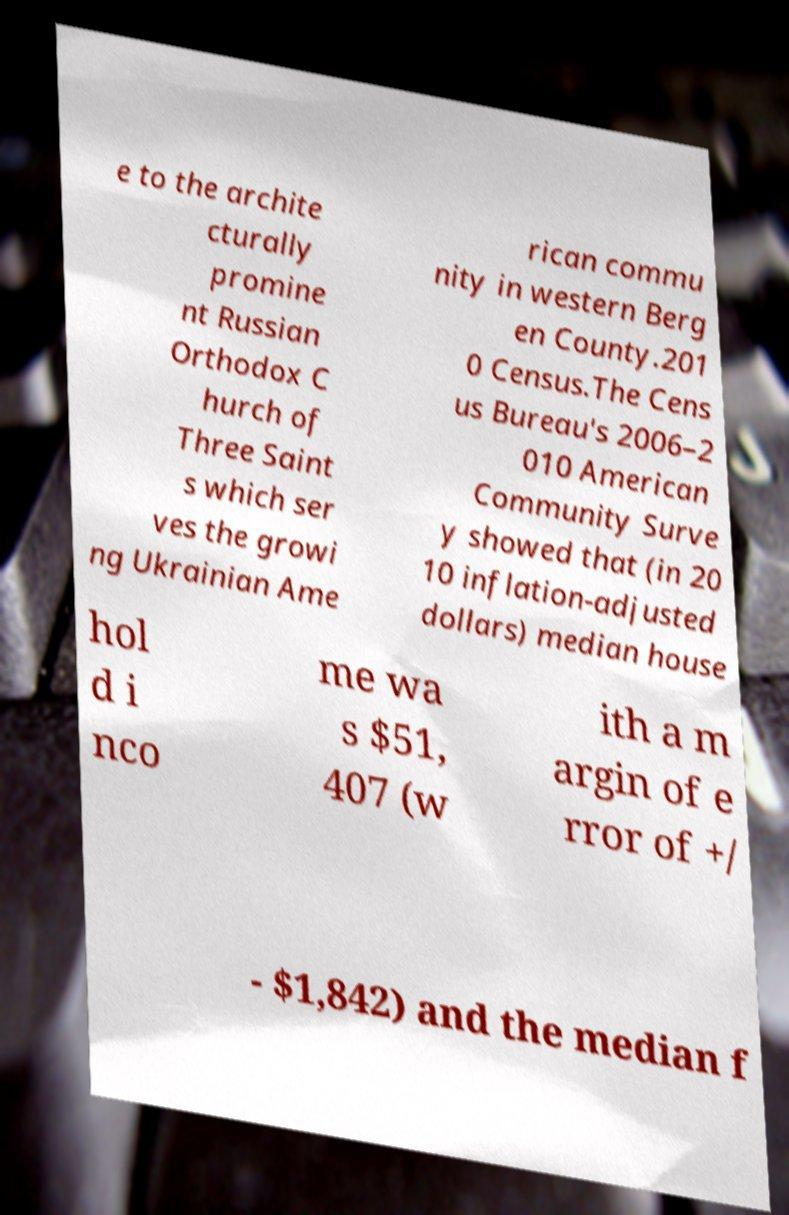Please identify and transcribe the text found in this image. e to the archite cturally promine nt Russian Orthodox C hurch of Three Saint s which ser ves the growi ng Ukrainian Ame rican commu nity in western Berg en County.201 0 Census.The Cens us Bureau's 2006–2 010 American Community Surve y showed that (in 20 10 inflation-adjusted dollars) median house hol d i nco me wa s $51, 407 (w ith a m argin of e rror of +/ - $1,842) and the median f 